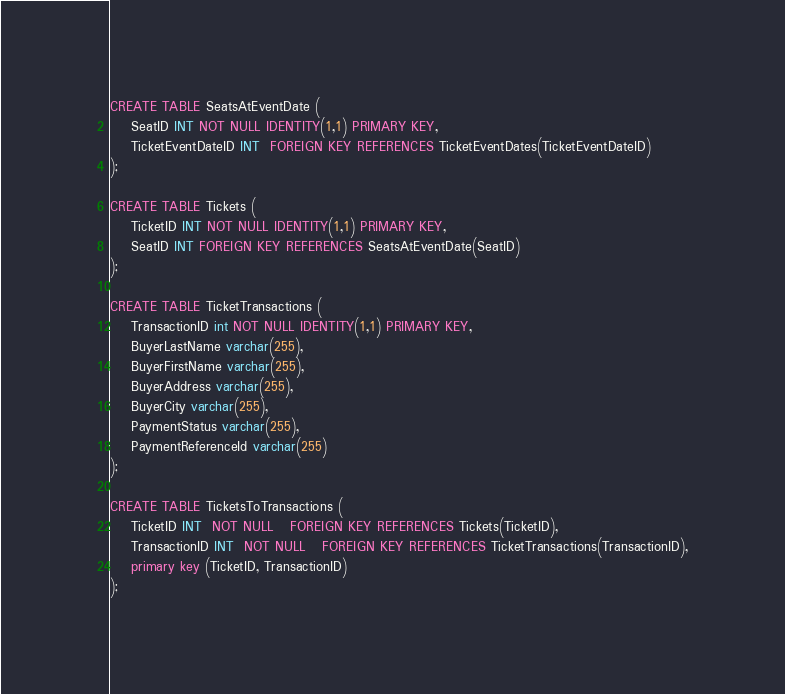<code> <loc_0><loc_0><loc_500><loc_500><_SQL_>



CREATE TABLE SeatsAtEventDate (
    SeatID INT NOT NULL IDENTITY(1,1) PRIMARY KEY,
	TicketEventDateID INT  FOREIGN KEY REFERENCES TicketEventDates(TicketEventDateID)
);

CREATE TABLE Tickets (
    TicketID INT NOT NULL IDENTITY(1,1) PRIMARY KEY,
	SeatID INT FOREIGN KEY REFERENCES SeatsAtEventDate(SeatID)
);

CREATE TABLE TicketTransactions (
    TransactionID int NOT NULL IDENTITY(1,1) PRIMARY KEY,
    BuyerLastName varchar(255),
    BuyerFirstName varchar(255),
    BuyerAddress varchar(255),
    BuyerCity varchar(255),
	PaymentStatus varchar(255),
	PaymentReferenceId varchar(255)
);

CREATE TABLE TicketsToTransactions (
    TicketID INT  NOT NULL   FOREIGN KEY REFERENCES Tickets(TicketID),
	TransactionID INT  NOT NULL   FOREIGN KEY REFERENCES TicketTransactions(TransactionID),
	primary key (TicketID, TransactionID)
);

</code> 